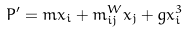<formula> <loc_0><loc_0><loc_500><loc_500>P ^ { \prime } = m x _ { i } + m ^ { W } _ { i j } x _ { j } + g x _ { i } ^ { 3 }</formula> 